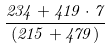<formula> <loc_0><loc_0><loc_500><loc_500>\frac { 2 3 4 + 4 1 9 \cdot 7 } { ( 2 1 5 + 4 7 9 ) }</formula> 